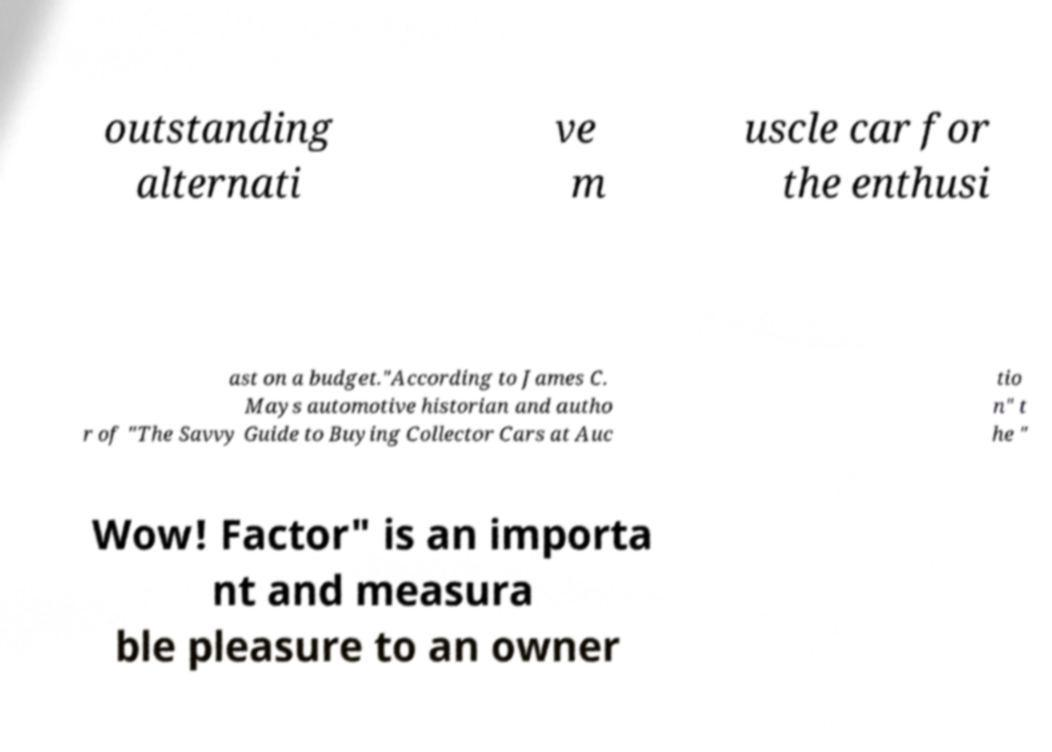Can you read and provide the text displayed in the image?This photo seems to have some interesting text. Can you extract and type it out for me? outstanding alternati ve m uscle car for the enthusi ast on a budget."According to James C. Mays automotive historian and autho r of "The Savvy Guide to Buying Collector Cars at Auc tio n" t he " Wow! Factor" is an importa nt and measura ble pleasure to an owner 